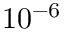Convert formula to latex. <formula><loc_0><loc_0><loc_500><loc_500>1 0 ^ { - 6 }</formula> 